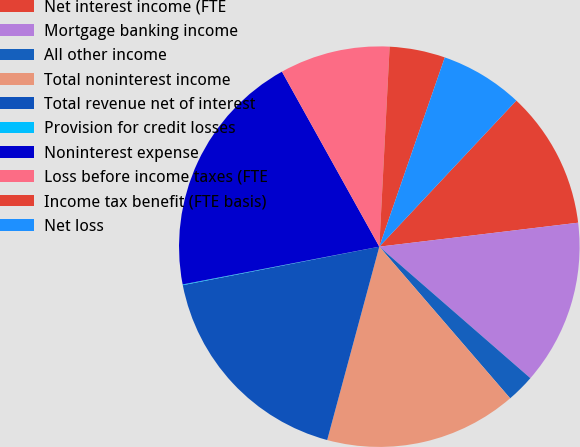Convert chart to OTSL. <chart><loc_0><loc_0><loc_500><loc_500><pie_chart><fcel>Net interest income (FTE<fcel>Mortgage banking income<fcel>All other income<fcel>Total noninterest income<fcel>Total revenue net of interest<fcel>Provision for credit losses<fcel>Noninterest expense<fcel>Loss before income taxes (FTE<fcel>Income tax benefit (FTE basis)<fcel>Net loss<nl><fcel>11.1%<fcel>13.31%<fcel>2.27%<fcel>15.52%<fcel>17.73%<fcel>0.06%<fcel>19.94%<fcel>8.9%<fcel>4.48%<fcel>6.69%<nl></chart> 